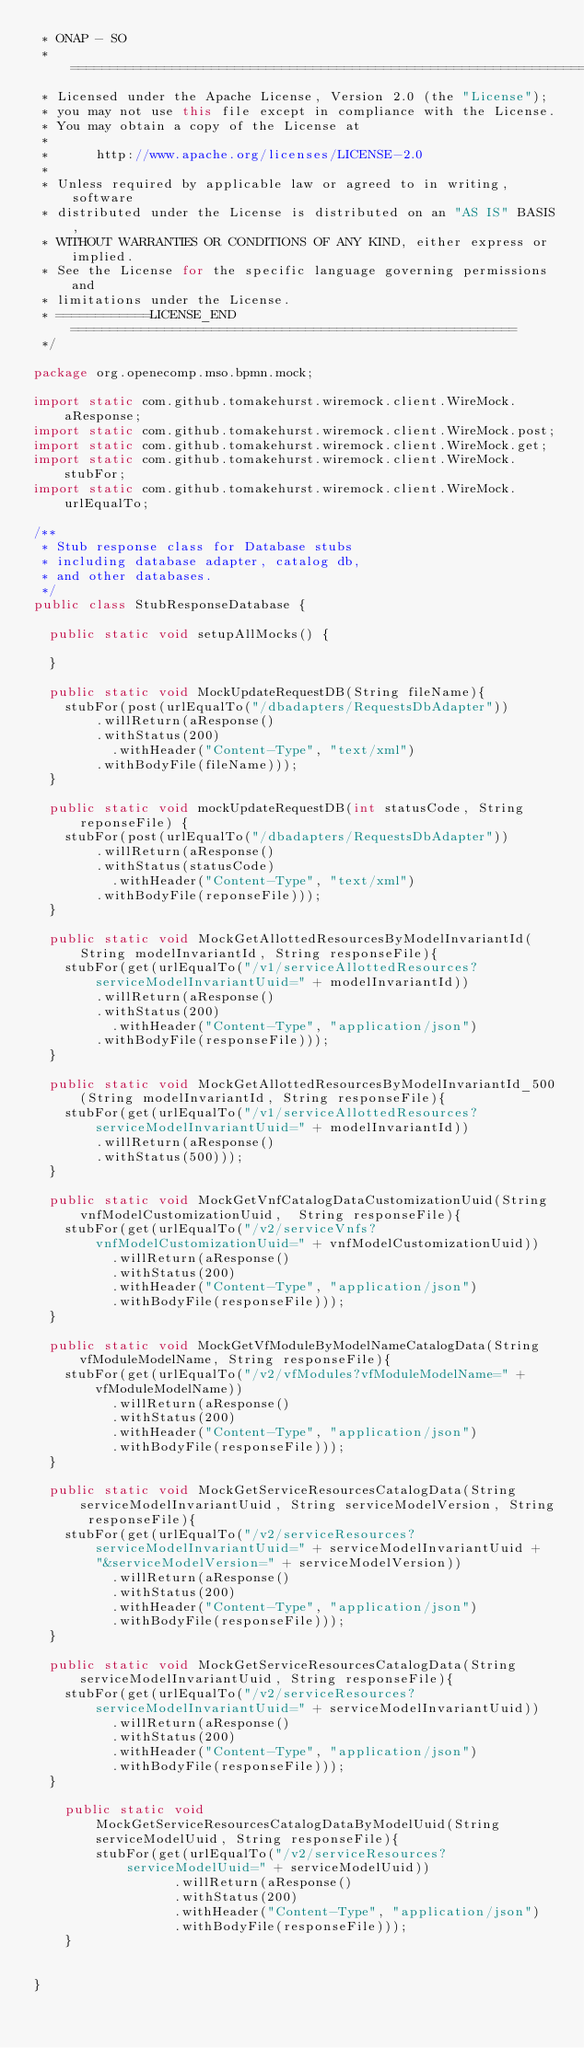Convert code to text. <code><loc_0><loc_0><loc_500><loc_500><_Java_> * ONAP - SO 
 * ================================================================================ 
 * Licensed under the Apache License, Version 2.0 (the "License"); 
 * you may not use this file except in compliance with the License. 
 * You may obtain a copy of the License at 
 * 
 *      http://www.apache.org/licenses/LICENSE-2.0 
 * 
 * Unless required by applicable law or agreed to in writing, software 
 * distributed under the License is distributed on an "AS IS" BASIS, 
 * WITHOUT WARRANTIES OR CONDITIONS OF ANY KIND, either express or implied. 
 * See the License for the specific language governing permissions and 
 * limitations under the License. 
 * ============LICENSE_END========================================================= 
 */ 

package org.openecomp.mso.bpmn.mock;

import static com.github.tomakehurst.wiremock.client.WireMock.aResponse;
import static com.github.tomakehurst.wiremock.client.WireMock.post;
import static com.github.tomakehurst.wiremock.client.WireMock.get;
import static com.github.tomakehurst.wiremock.client.WireMock.stubFor;
import static com.github.tomakehurst.wiremock.client.WireMock.urlEqualTo;

/**
 * Stub response class for Database stubs
 * including database adapter, catalog db,
 * and other databases.
 */
public class StubResponseDatabase {

	public static void setupAllMocks() {

	}

	public static void MockUpdateRequestDB(String fileName){
		stubFor(post(urlEqualTo("/dbadapters/RequestsDbAdapter"))
				.willReturn(aResponse()
				.withStatus(200)
			    .withHeader("Content-Type", "text/xml")
				.withBodyFile(fileName)));
	}	
	
	public static void mockUpdateRequestDB(int statusCode, String reponseFile) {
		stubFor(post(urlEqualTo("/dbadapters/RequestsDbAdapter"))
				.willReturn(aResponse()
				.withStatus(statusCode)
			    .withHeader("Content-Type", "text/xml")
				.withBodyFile(reponseFile)));
	}

	public static void MockGetAllottedResourcesByModelInvariantId(String modelInvariantId, String responseFile){
		stubFor(get(urlEqualTo("/v1/serviceAllottedResources?serviceModelInvariantUuid=" + modelInvariantId))
				.willReturn(aResponse()
				.withStatus(200)
			    .withHeader("Content-Type", "application/json")
				.withBodyFile(responseFile)));
	}

	public static void MockGetAllottedResourcesByModelInvariantId_500(String modelInvariantId, String responseFile){
		stubFor(get(urlEqualTo("/v1/serviceAllottedResources?serviceModelInvariantUuid=" + modelInvariantId))
				.willReturn(aResponse()
				.withStatus(500)));
	}
	
	public static void MockGetVnfCatalogDataCustomizationUuid(String vnfModelCustomizationUuid,  String responseFile){
		stubFor(get(urlEqualTo("/v2/serviceVnfs?vnfModelCustomizationUuid=" + vnfModelCustomizationUuid))
				  .willReturn(aResponse()
				  .withStatus(200)
				  .withHeader("Content-Type", "application/json")
				  .withBodyFile(responseFile)));
	}

	public static void MockGetVfModuleByModelNameCatalogData(String vfModuleModelName, String responseFile){
		stubFor(get(urlEqualTo("/v2/vfModules?vfModuleModelName=" + vfModuleModelName))
				  .willReturn(aResponse()
				  .withStatus(200)
				  .withHeader("Content-Type", "application/json")
				  .withBodyFile(responseFile)));
	}
	
	public static void MockGetServiceResourcesCatalogData(String serviceModelInvariantUuid, String serviceModelVersion, String responseFile){
		stubFor(get(urlEqualTo("/v2/serviceResources?serviceModelInvariantUuid=" + serviceModelInvariantUuid + 
				"&serviceModelVersion=" + serviceModelVersion))
				  .willReturn(aResponse()
				  .withStatus(200)
				  .withHeader("Content-Type", "application/json")
				  .withBodyFile(responseFile)));
	}
	
	public static void MockGetServiceResourcesCatalogData(String serviceModelInvariantUuid, String responseFile){
		stubFor(get(urlEqualTo("/v2/serviceResources?serviceModelInvariantUuid=" + serviceModelInvariantUuid))
				  .willReturn(aResponse()
				  .withStatus(200)
				  .withHeader("Content-Type", "application/json")
				  .withBodyFile(responseFile)));
	}	
	
    public static void MockGetServiceResourcesCatalogDataByModelUuid(String serviceModelUuid, String responseFile){
        stubFor(get(urlEqualTo("/v2/serviceResources?serviceModelUuid=" + serviceModelUuid))
                  .willReturn(aResponse()
                  .withStatus(200)
                  .withHeader("Content-Type", "application/json")
                  .withBodyFile(responseFile)));
    }	
	

}
</code> 